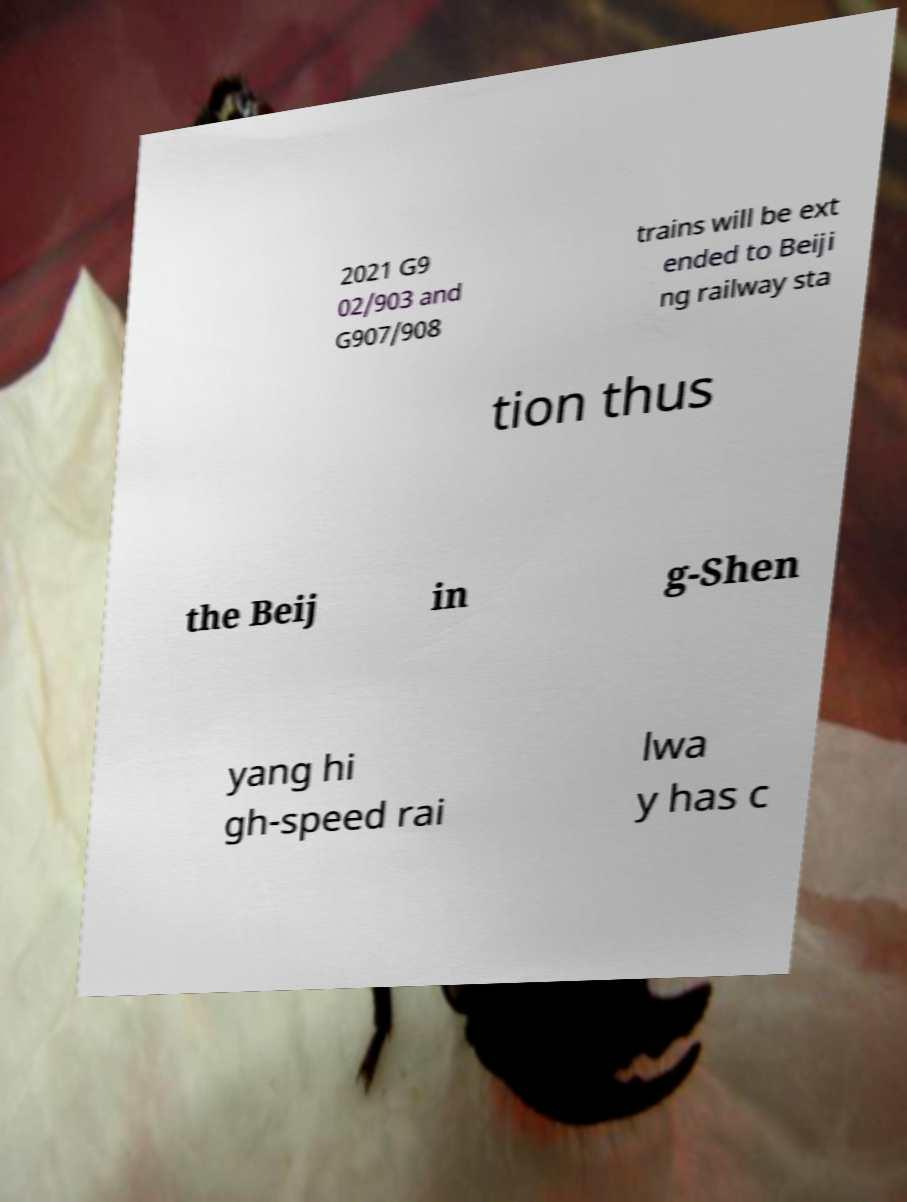Please read and relay the text visible in this image. What does it say? 2021 G9 02/903 and G907/908 trains will be ext ended to Beiji ng railway sta tion thus the Beij in g-Shen yang hi gh-speed rai lwa y has c 